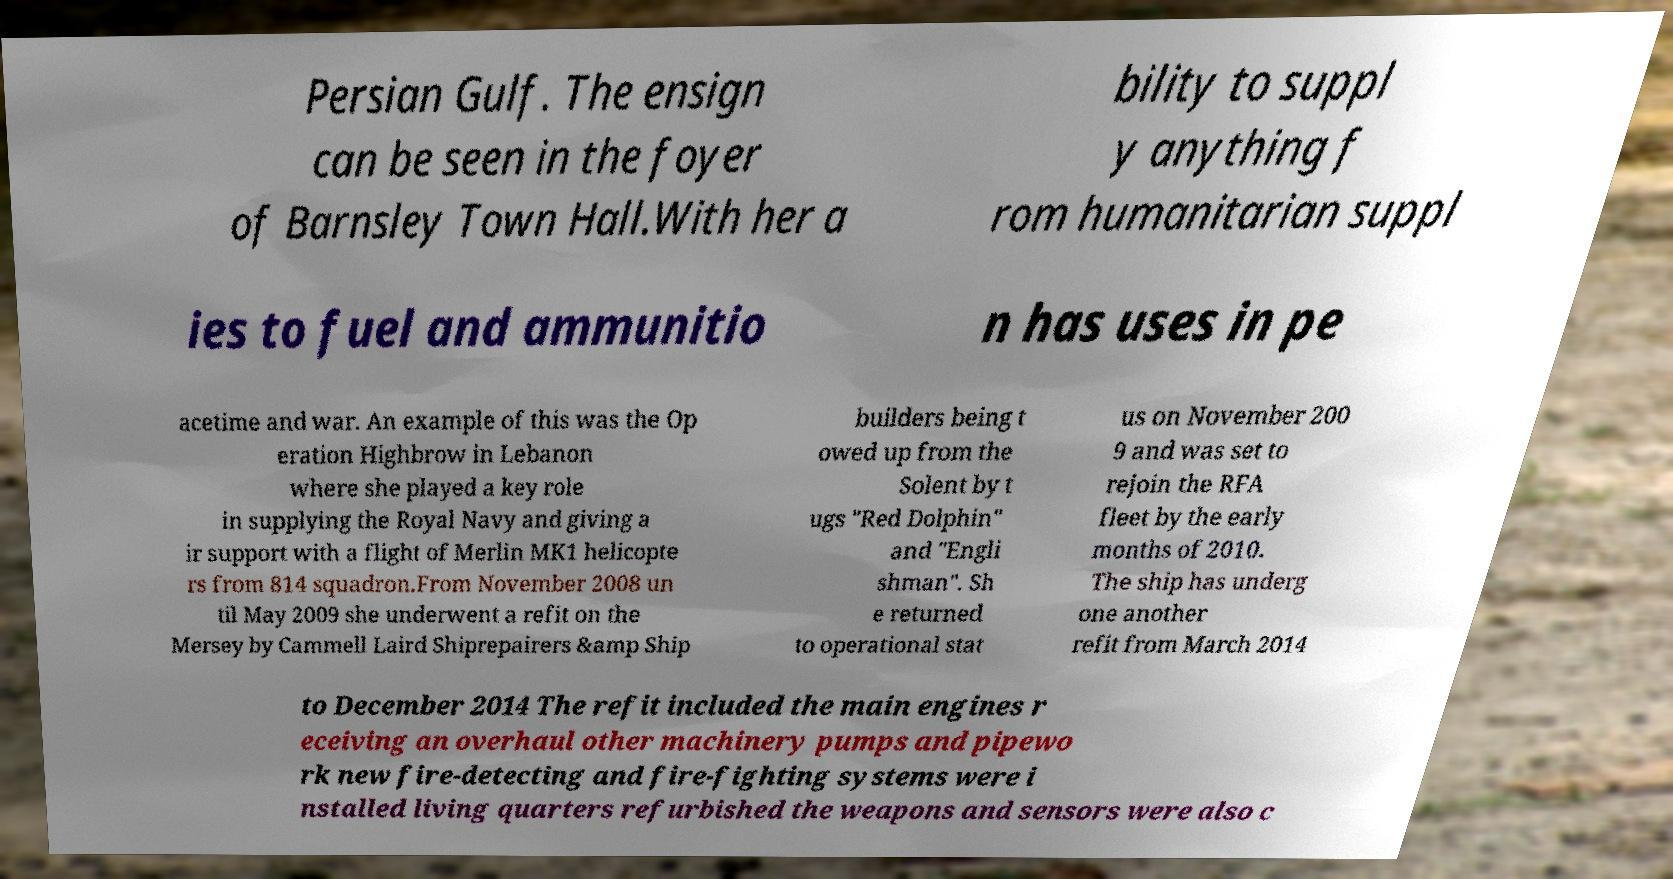For documentation purposes, I need the text within this image transcribed. Could you provide that? Persian Gulf. The ensign can be seen in the foyer of Barnsley Town Hall.With her a bility to suppl y anything f rom humanitarian suppl ies to fuel and ammunitio n has uses in pe acetime and war. An example of this was the Op eration Highbrow in Lebanon where she played a key role in supplying the Royal Navy and giving a ir support with a flight of Merlin MK1 helicopte rs from 814 squadron.From November 2008 un til May 2009 she underwent a refit on the Mersey by Cammell Laird Shiprepairers &amp Ship builders being t owed up from the Solent by t ugs "Red Dolphin" and "Engli shman". Sh e returned to operational stat us on November 200 9 and was set to rejoin the RFA fleet by the early months of 2010. The ship has underg one another refit from March 2014 to December 2014 The refit included the main engines r eceiving an overhaul other machinery pumps and pipewo rk new fire-detecting and fire-fighting systems were i nstalled living quarters refurbished the weapons and sensors were also c 